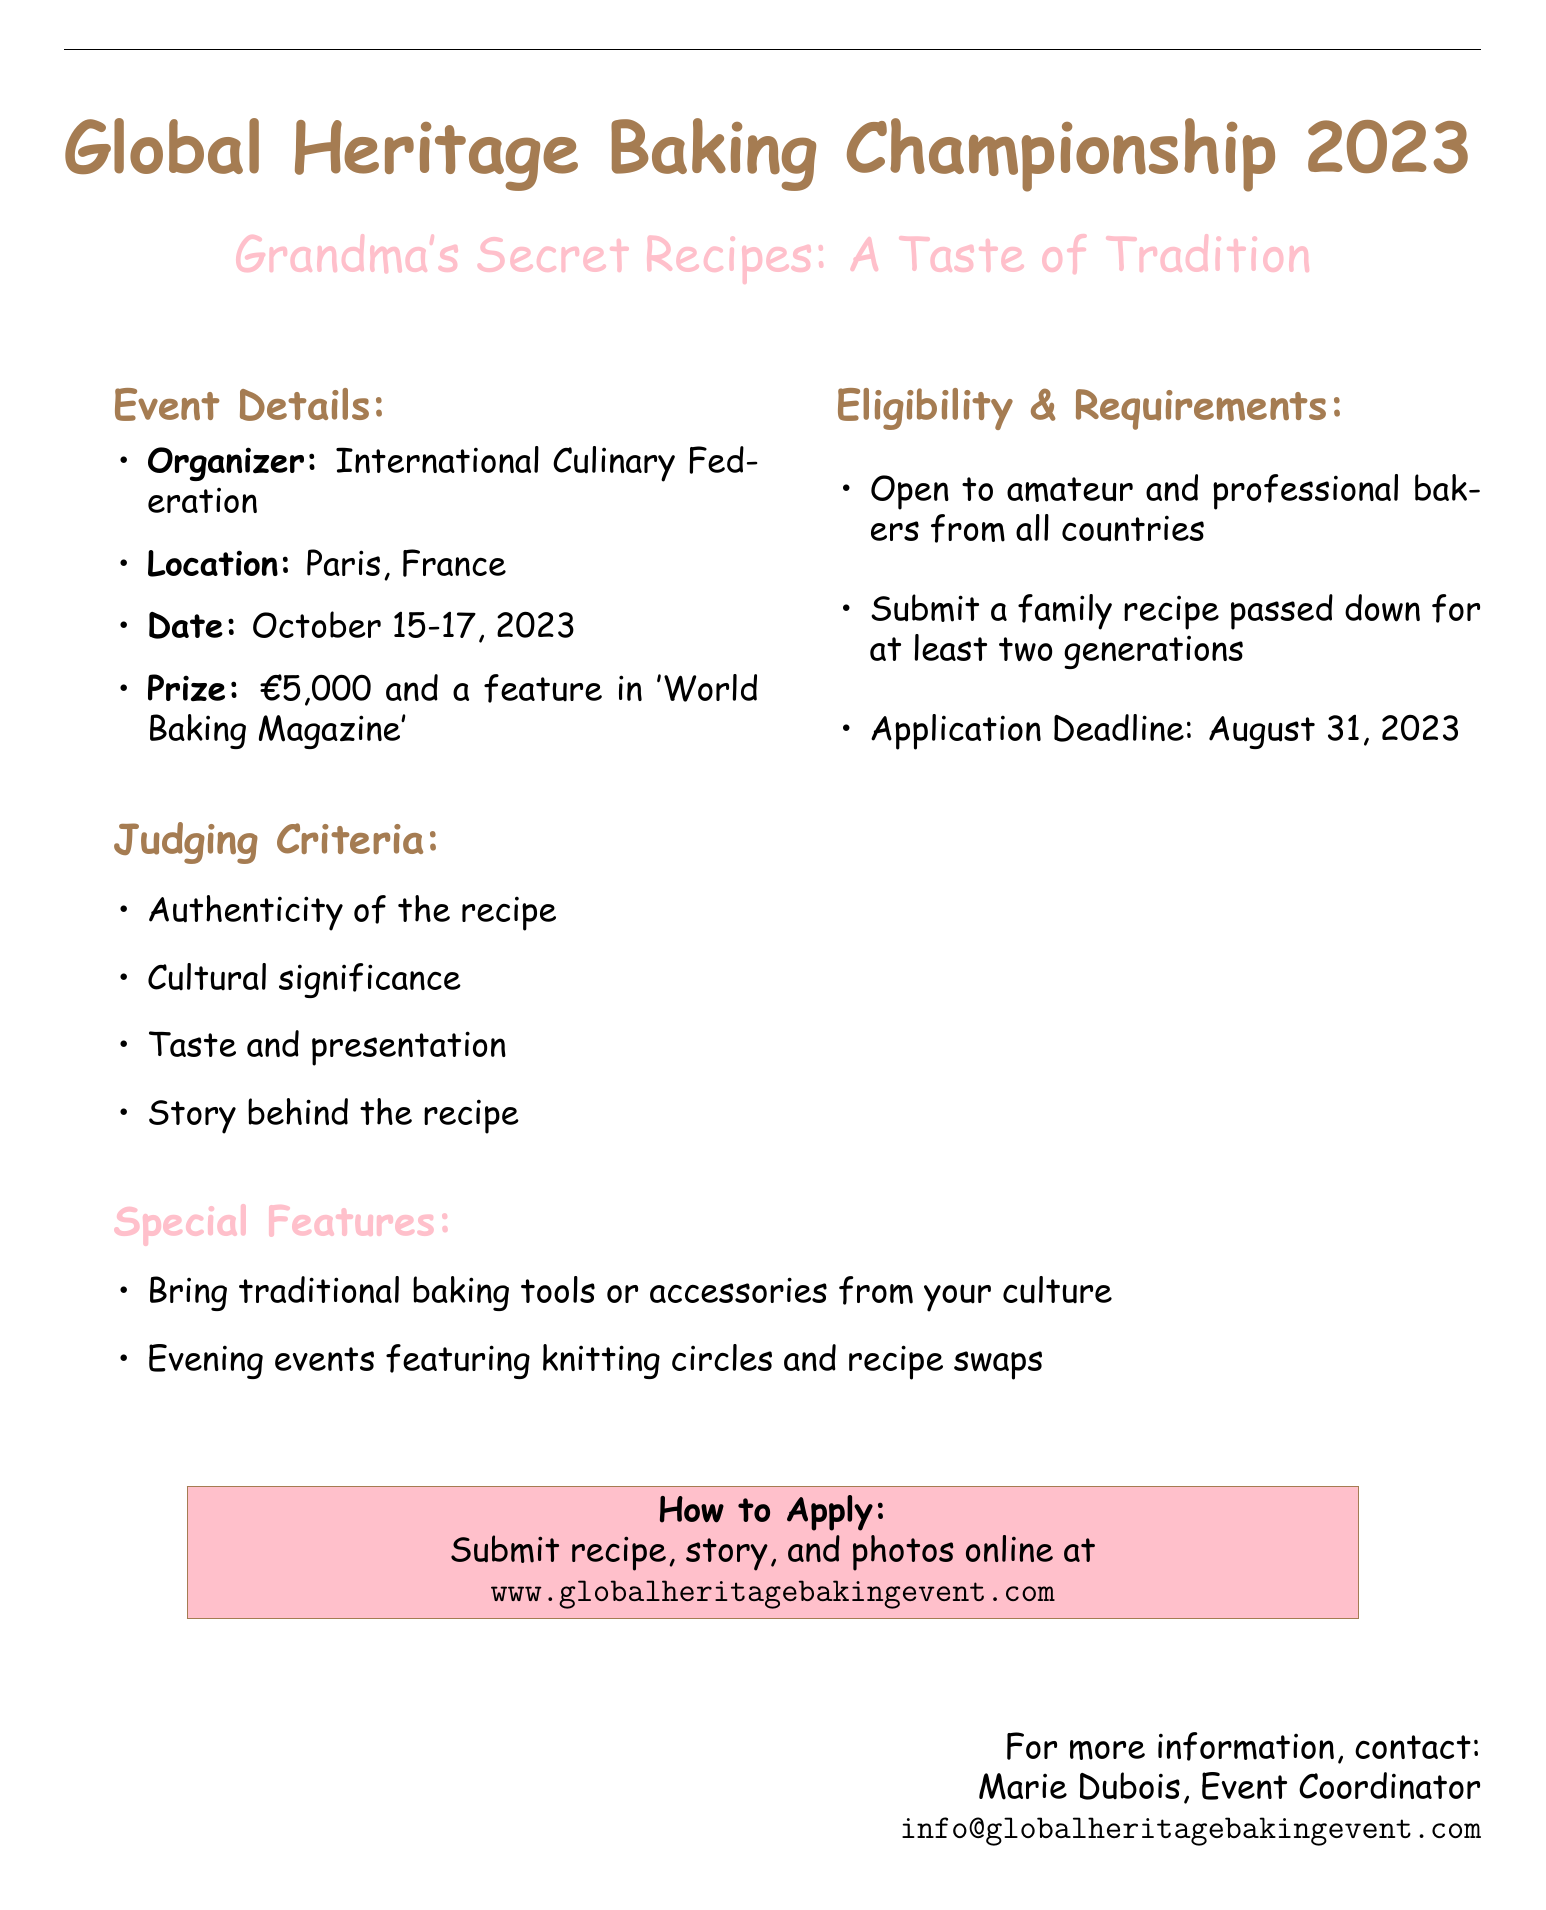What is the name of the event? The event is called "Global Heritage Baking Championship 2023."
Answer: Global Heritage Baking Championship 2023 Who is the organizer of the event? The document states that the organizer is the "International Culinary Federation."
Answer: International Culinary Federation What are the dates of the competition? The competition is taking place from October 15 to October 17, 2023.
Answer: October 15-17, 2023 What is the prize for the competition? Participants can win a prize of €5,000 and a feature in "World Baking Magazine."
Answer: €5,000 and a feature in 'World Baking Magazine' What is one of the eligibility requirements? One eligibility requirement is to submit a family recipe passed down for at least two generations.
Answer: Submit a family recipe that has been passed down for at least two generations What will participants do during evening events? The evening events will feature knitting circles and recipe swaps among participants.
Answer: Knitting circles and recipe swaps Who should participants contact for more information? For more information, participants should contact Marie Dubois, the Event Coordinator.
Answer: Marie Dubois How can participants apply? Participants can apply by submitting their recipe, story, and photos online.
Answer: Submit recipe, story, and photos online at www.globalheritagebakingevent.com 